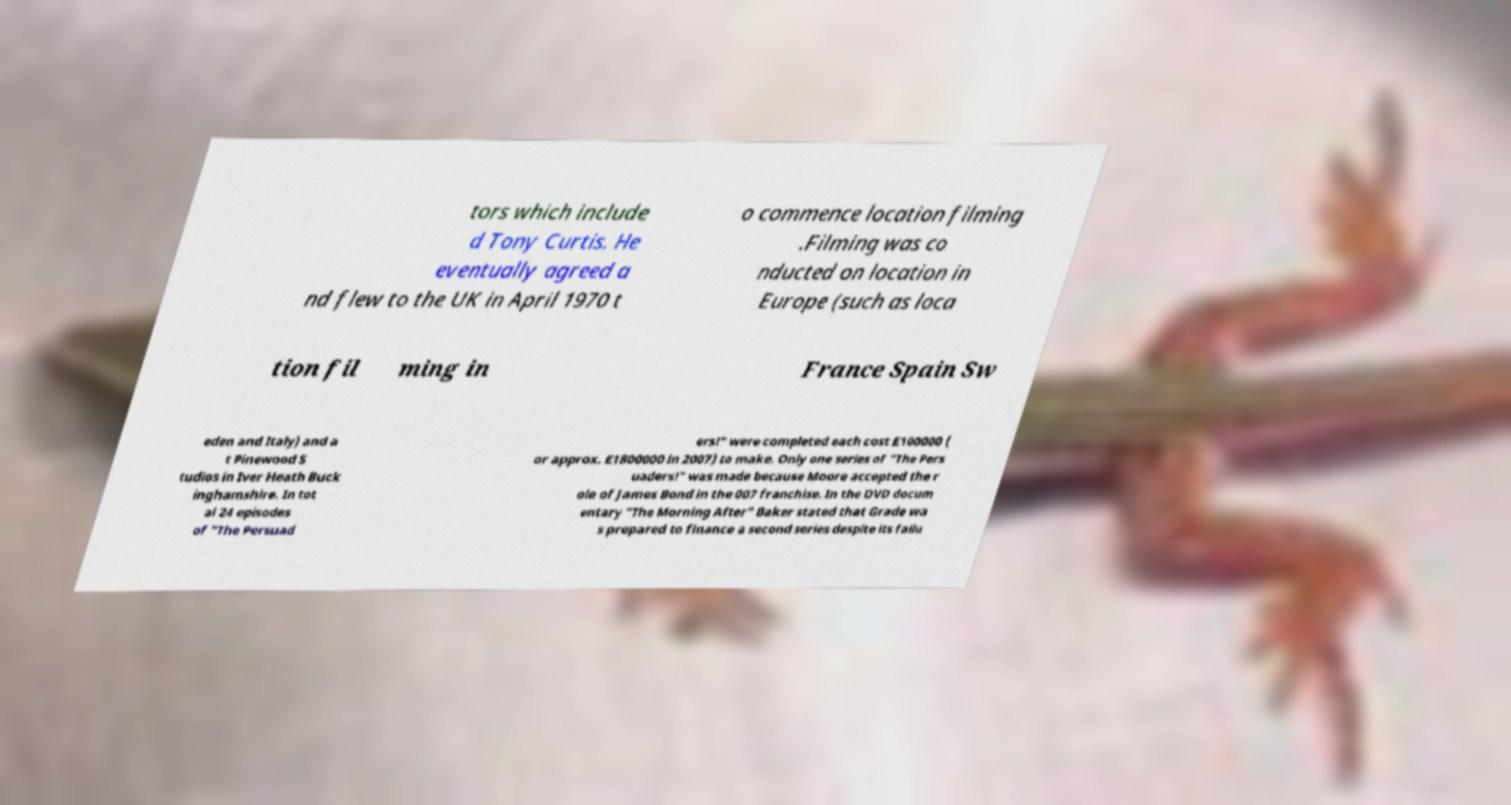For documentation purposes, I need the text within this image transcribed. Could you provide that? tors which include d Tony Curtis. He eventually agreed a nd flew to the UK in April 1970 t o commence location filming .Filming was co nducted on location in Europe (such as loca tion fil ming in France Spain Sw eden and Italy) and a t Pinewood S tudios in Iver Heath Buck inghamshire. In tot al 24 episodes of "The Persuad ers!" were completed each cost £100000 ( or approx. £1800000 in 2007) to make. Only one series of "The Pers uaders!" was made because Moore accepted the r ole of James Bond in the 007 franchise. In the DVD docum entary "The Morning After" Baker stated that Grade wa s prepared to finance a second series despite its failu 